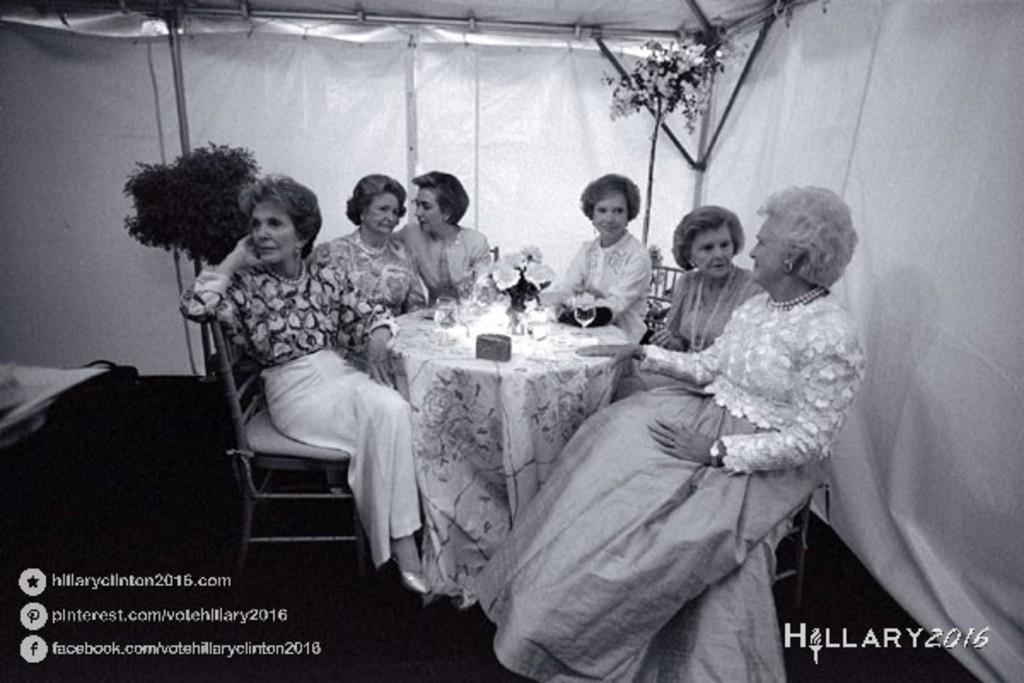Describe this image in one or two sentences. In this image we have 3 women at the right side sitting in chair , another 3 women at the left side sitting in chair and at the back ground we have a tent , plant and table with some flower pot and some glasses. 